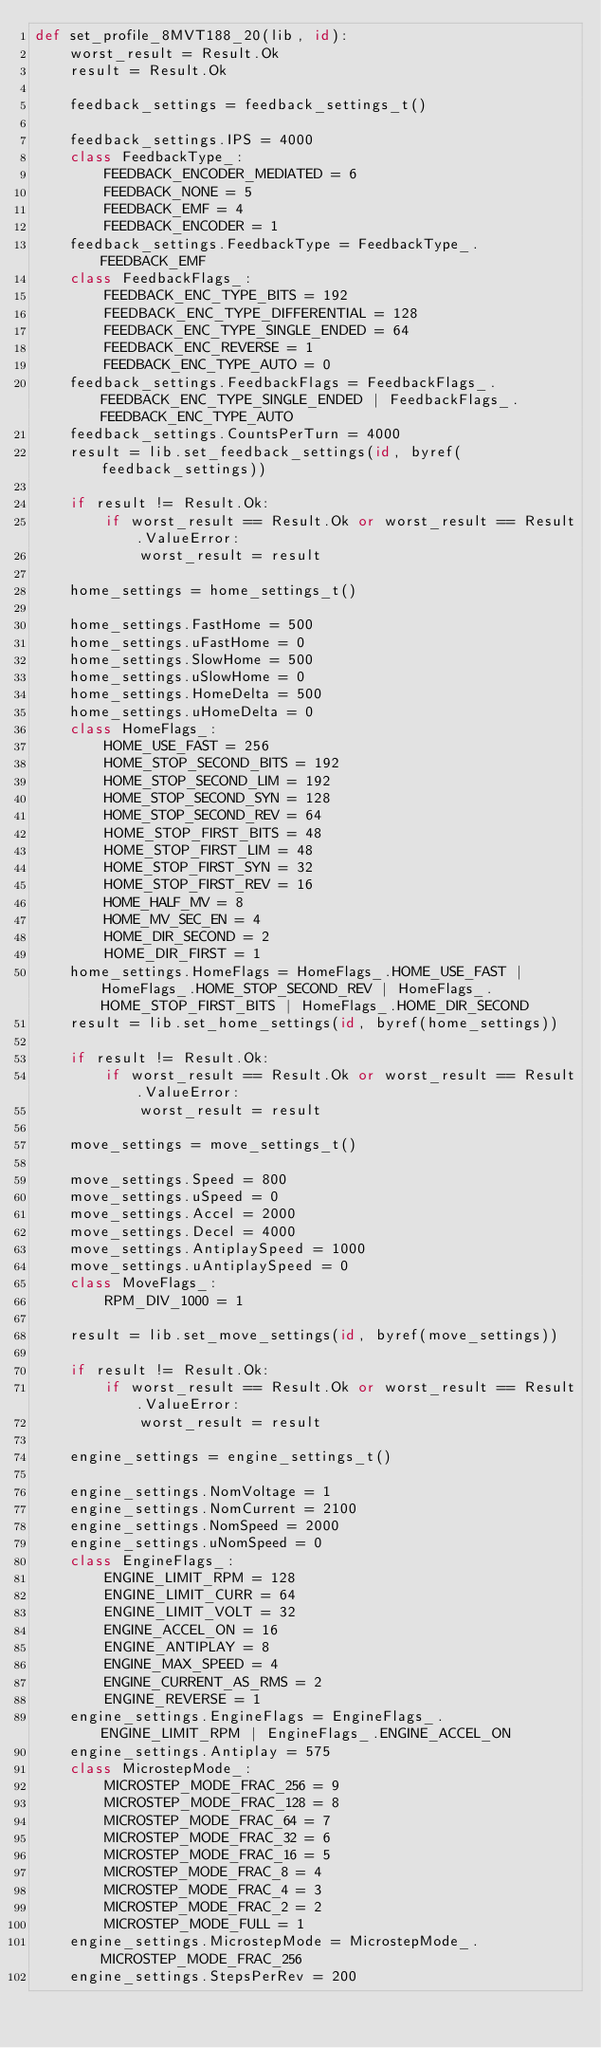Convert code to text. <code><loc_0><loc_0><loc_500><loc_500><_Python_>def set_profile_8MVT188_20(lib, id):
    worst_result = Result.Ok
    result = Result.Ok

    feedback_settings = feedback_settings_t()

    feedback_settings.IPS = 4000
    class FeedbackType_:
        FEEDBACK_ENCODER_MEDIATED = 6
        FEEDBACK_NONE = 5
        FEEDBACK_EMF = 4
        FEEDBACK_ENCODER = 1
    feedback_settings.FeedbackType = FeedbackType_.FEEDBACK_EMF
    class FeedbackFlags_:
        FEEDBACK_ENC_TYPE_BITS = 192
        FEEDBACK_ENC_TYPE_DIFFERENTIAL = 128
        FEEDBACK_ENC_TYPE_SINGLE_ENDED = 64
        FEEDBACK_ENC_REVERSE = 1
        FEEDBACK_ENC_TYPE_AUTO = 0
    feedback_settings.FeedbackFlags = FeedbackFlags_.FEEDBACK_ENC_TYPE_SINGLE_ENDED | FeedbackFlags_.FEEDBACK_ENC_TYPE_AUTO
    feedback_settings.CountsPerTurn = 4000
    result = lib.set_feedback_settings(id, byref(feedback_settings))

    if result != Result.Ok:
        if worst_result == Result.Ok or worst_result == Result.ValueError:
            worst_result = result

    home_settings = home_settings_t()

    home_settings.FastHome = 500
    home_settings.uFastHome = 0
    home_settings.SlowHome = 500
    home_settings.uSlowHome = 0
    home_settings.HomeDelta = 500
    home_settings.uHomeDelta = 0
    class HomeFlags_:
        HOME_USE_FAST = 256
        HOME_STOP_SECOND_BITS = 192
        HOME_STOP_SECOND_LIM = 192
        HOME_STOP_SECOND_SYN = 128
        HOME_STOP_SECOND_REV = 64
        HOME_STOP_FIRST_BITS = 48
        HOME_STOP_FIRST_LIM = 48
        HOME_STOP_FIRST_SYN = 32
        HOME_STOP_FIRST_REV = 16
        HOME_HALF_MV = 8
        HOME_MV_SEC_EN = 4
        HOME_DIR_SECOND = 2
        HOME_DIR_FIRST = 1
    home_settings.HomeFlags = HomeFlags_.HOME_USE_FAST | HomeFlags_.HOME_STOP_SECOND_REV | HomeFlags_.HOME_STOP_FIRST_BITS | HomeFlags_.HOME_DIR_SECOND
    result = lib.set_home_settings(id, byref(home_settings))

    if result != Result.Ok:
        if worst_result == Result.Ok or worst_result == Result.ValueError:
            worst_result = result

    move_settings = move_settings_t()

    move_settings.Speed = 800
    move_settings.uSpeed = 0
    move_settings.Accel = 2000
    move_settings.Decel = 4000
    move_settings.AntiplaySpeed = 1000
    move_settings.uAntiplaySpeed = 0
    class MoveFlags_:
        RPM_DIV_1000 = 1

    result = lib.set_move_settings(id, byref(move_settings))

    if result != Result.Ok:
        if worst_result == Result.Ok or worst_result == Result.ValueError:
            worst_result = result

    engine_settings = engine_settings_t()

    engine_settings.NomVoltage = 1
    engine_settings.NomCurrent = 2100
    engine_settings.NomSpeed = 2000
    engine_settings.uNomSpeed = 0
    class EngineFlags_:
        ENGINE_LIMIT_RPM = 128
        ENGINE_LIMIT_CURR = 64
        ENGINE_LIMIT_VOLT = 32
        ENGINE_ACCEL_ON = 16
        ENGINE_ANTIPLAY = 8
        ENGINE_MAX_SPEED = 4
        ENGINE_CURRENT_AS_RMS = 2
        ENGINE_REVERSE = 1
    engine_settings.EngineFlags = EngineFlags_.ENGINE_LIMIT_RPM | EngineFlags_.ENGINE_ACCEL_ON
    engine_settings.Antiplay = 575
    class MicrostepMode_:
        MICROSTEP_MODE_FRAC_256 = 9
        MICROSTEP_MODE_FRAC_128 = 8
        MICROSTEP_MODE_FRAC_64 = 7
        MICROSTEP_MODE_FRAC_32 = 6
        MICROSTEP_MODE_FRAC_16 = 5
        MICROSTEP_MODE_FRAC_8 = 4
        MICROSTEP_MODE_FRAC_4 = 3
        MICROSTEP_MODE_FRAC_2 = 2
        MICROSTEP_MODE_FULL = 1
    engine_settings.MicrostepMode = MicrostepMode_.MICROSTEP_MODE_FRAC_256
    engine_settings.StepsPerRev = 200</code> 